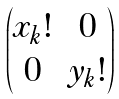<formula> <loc_0><loc_0><loc_500><loc_500>\begin{pmatrix} x _ { k } ! & 0 \\ 0 & y _ { k } ! \end{pmatrix}</formula> 